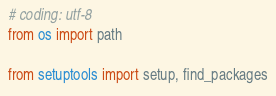Convert code to text. <code><loc_0><loc_0><loc_500><loc_500><_Python_># coding: utf-8
from os import path

from setuptools import setup, find_packages
</code> 